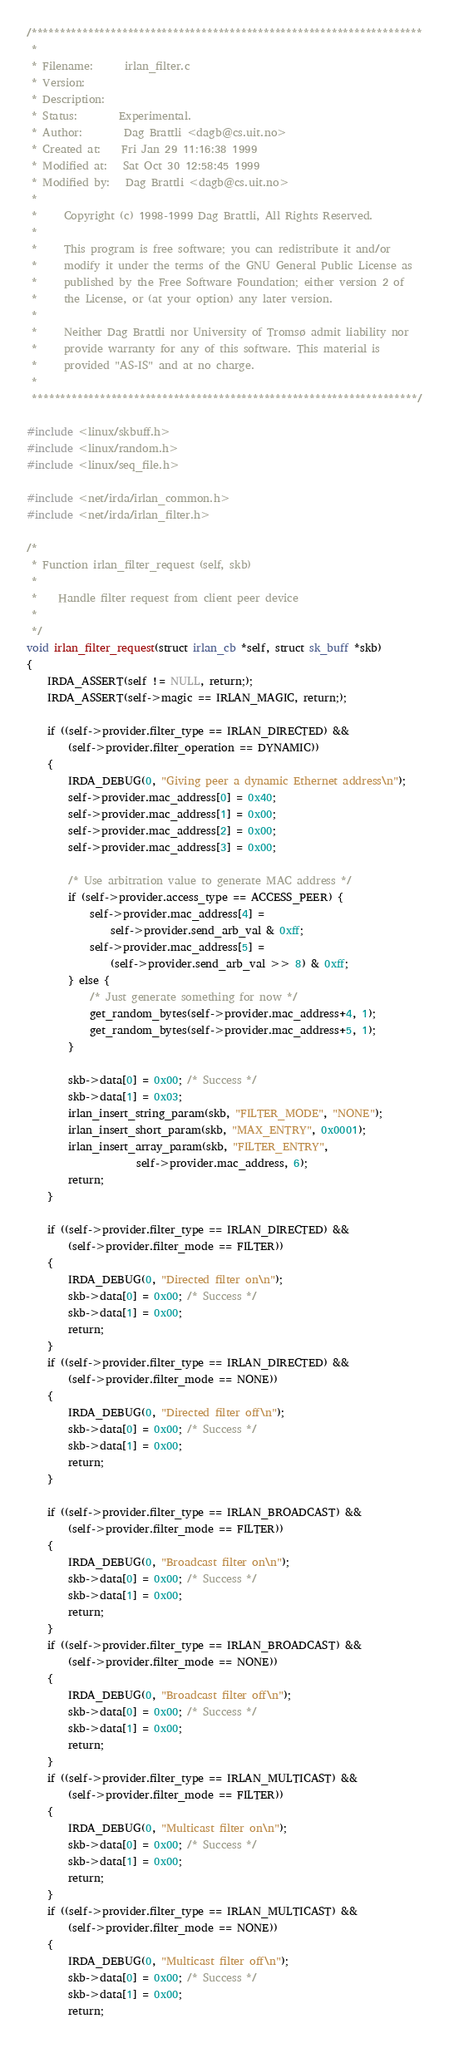Convert code to text. <code><loc_0><loc_0><loc_500><loc_500><_C_>/*********************************************************************
 *
 * Filename:      irlan_filter.c
 * Version:
 * Description:
 * Status:        Experimental.
 * Author:        Dag Brattli <dagb@cs.uit.no>
 * Created at:    Fri Jan 29 11:16:38 1999
 * Modified at:   Sat Oct 30 12:58:45 1999
 * Modified by:   Dag Brattli <dagb@cs.uit.no>
 *
 *     Copyright (c) 1998-1999 Dag Brattli, All Rights Reserved.
 *
 *     This program is free software; you can redistribute it and/or
 *     modify it under the terms of the GNU General Public License as
 *     published by the Free Software Foundation; either version 2 of
 *     the License, or (at your option) any later version.
 *
 *     Neither Dag Brattli nor University of Tromsø admit liability nor
 *     provide warranty for any of this software. This material is
 *     provided "AS-IS" and at no charge.
 *
 ********************************************************************/

#include <linux/skbuff.h>
#include <linux/random.h>
#include <linux/seq_file.h>

#include <net/irda/irlan_common.h>
#include <net/irda/irlan_filter.h>

/*
 * Function irlan_filter_request (self, skb)
 *
 *    Handle filter request from client peer device
 *
 */
void irlan_filter_request(struct irlan_cb *self, struct sk_buff *skb)
{
	IRDA_ASSERT(self != NULL, return;);
	IRDA_ASSERT(self->magic == IRLAN_MAGIC, return;);

	if ((self->provider.filter_type == IRLAN_DIRECTED) &&
	    (self->provider.filter_operation == DYNAMIC))
	{
		IRDA_DEBUG(0, "Giving peer a dynamic Ethernet address\n");
		self->provider.mac_address[0] = 0x40;
		self->provider.mac_address[1] = 0x00;
		self->provider.mac_address[2] = 0x00;
		self->provider.mac_address[3] = 0x00;

		/* Use arbitration value to generate MAC address */
		if (self->provider.access_type == ACCESS_PEER) {
			self->provider.mac_address[4] =
				self->provider.send_arb_val & 0xff;
			self->provider.mac_address[5] =
				(self->provider.send_arb_val >> 8) & 0xff;
		} else {
			/* Just generate something for now */
			get_random_bytes(self->provider.mac_address+4, 1);
			get_random_bytes(self->provider.mac_address+5, 1);
		}

		skb->data[0] = 0x00; /* Success */
		skb->data[1] = 0x03;
		irlan_insert_string_param(skb, "FILTER_MODE", "NONE");
		irlan_insert_short_param(skb, "MAX_ENTRY", 0x0001);
		irlan_insert_array_param(skb, "FILTER_ENTRY",
					 self->provider.mac_address, 6);
		return;
	}

	if ((self->provider.filter_type == IRLAN_DIRECTED) &&
	    (self->provider.filter_mode == FILTER))
	{
		IRDA_DEBUG(0, "Directed filter on\n");
		skb->data[0] = 0x00; /* Success */
		skb->data[1] = 0x00;
		return;
	}
	if ((self->provider.filter_type == IRLAN_DIRECTED) &&
	    (self->provider.filter_mode == NONE))
	{
		IRDA_DEBUG(0, "Directed filter off\n");
		skb->data[0] = 0x00; /* Success */
		skb->data[1] = 0x00;
		return;
	}

	if ((self->provider.filter_type == IRLAN_BROADCAST) &&
	    (self->provider.filter_mode == FILTER))
	{
		IRDA_DEBUG(0, "Broadcast filter on\n");
		skb->data[0] = 0x00; /* Success */
		skb->data[1] = 0x00;
		return;
	}
	if ((self->provider.filter_type == IRLAN_BROADCAST) &&
	    (self->provider.filter_mode == NONE))
	{
		IRDA_DEBUG(0, "Broadcast filter off\n");
		skb->data[0] = 0x00; /* Success */
		skb->data[1] = 0x00;
		return;
	}
	if ((self->provider.filter_type == IRLAN_MULTICAST) &&
	    (self->provider.filter_mode == FILTER))
	{
		IRDA_DEBUG(0, "Multicast filter on\n");
		skb->data[0] = 0x00; /* Success */
		skb->data[1] = 0x00;
		return;
	}
	if ((self->provider.filter_type == IRLAN_MULTICAST) &&
	    (self->provider.filter_mode == NONE))
	{
		IRDA_DEBUG(0, "Multicast filter off\n");
		skb->data[0] = 0x00; /* Success */
		skb->data[1] = 0x00;
		return;</code> 